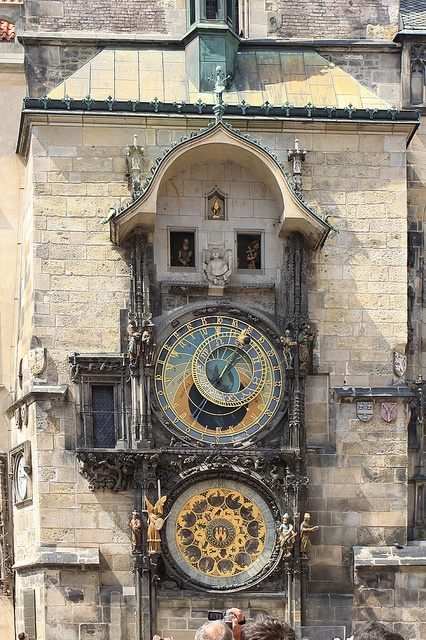Describe the objects in this image and their specific colors. I can see clock in beige, gray, black, tan, and khaki tones, clock in beige, tan, gray, and khaki tones, people in beige, gray, black, darkgray, and maroon tones, people in beige, gray, darkgray, and black tones, and people in beige, lightgray, tan, and darkgray tones in this image. 